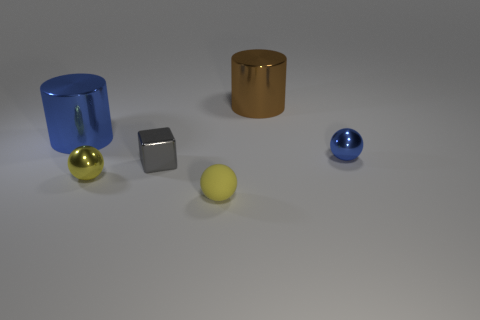Is the shape of the yellow metallic thing the same as the small metal thing that is behind the small gray metal cube?
Make the answer very short. Yes. How many blue metallic objects have the same size as the gray metal cube?
Ensure brevity in your answer.  1. There is another tiny yellow thing that is the same shape as the yellow metal thing; what is its material?
Provide a short and direct response. Rubber. Do the small thing that is in front of the yellow shiny sphere and the small metal thing to the right of the gray object have the same color?
Provide a succinct answer. No. There is a blue metallic thing that is to the left of the tiny gray metal block; what is its shape?
Ensure brevity in your answer.  Cylinder. The tiny metallic block is what color?
Your response must be concise. Gray. There is a blue thing that is made of the same material as the small blue sphere; what shape is it?
Your answer should be compact. Cylinder. There is a sphere to the right of the brown metallic thing; is it the same size as the brown cylinder?
Ensure brevity in your answer.  No. How many things are either tiny metallic objects right of the brown cylinder or tiny yellow balls that are on the left side of the small metal block?
Keep it short and to the point. 2. Do the tiny metallic sphere left of the small rubber ball and the tiny rubber ball have the same color?
Your answer should be very brief. Yes. 